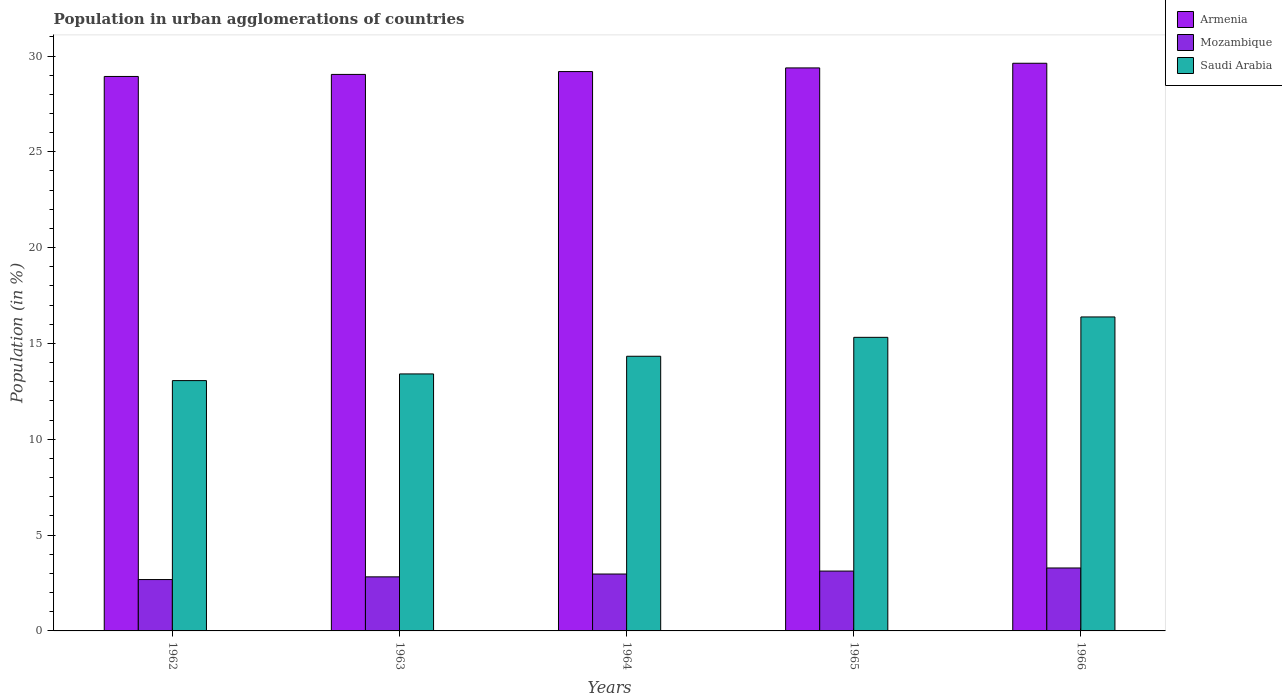How many different coloured bars are there?
Provide a succinct answer. 3. How many groups of bars are there?
Provide a succinct answer. 5. Are the number of bars per tick equal to the number of legend labels?
Give a very brief answer. Yes. Are the number of bars on each tick of the X-axis equal?
Your answer should be compact. Yes. How many bars are there on the 3rd tick from the left?
Give a very brief answer. 3. How many bars are there on the 3rd tick from the right?
Your answer should be compact. 3. What is the label of the 4th group of bars from the left?
Give a very brief answer. 1965. What is the percentage of population in urban agglomerations in Mozambique in 1966?
Your response must be concise. 3.28. Across all years, what is the maximum percentage of population in urban agglomerations in Saudi Arabia?
Provide a succinct answer. 16.38. Across all years, what is the minimum percentage of population in urban agglomerations in Armenia?
Keep it short and to the point. 28.93. In which year was the percentage of population in urban agglomerations in Saudi Arabia maximum?
Offer a terse response. 1966. What is the total percentage of population in urban agglomerations in Mozambique in the graph?
Give a very brief answer. 14.88. What is the difference between the percentage of population in urban agglomerations in Mozambique in 1962 and that in 1965?
Your response must be concise. -0.44. What is the difference between the percentage of population in urban agglomerations in Mozambique in 1966 and the percentage of population in urban agglomerations in Armenia in 1962?
Offer a very short reply. -25.65. What is the average percentage of population in urban agglomerations in Mozambique per year?
Give a very brief answer. 2.98. In the year 1964, what is the difference between the percentage of population in urban agglomerations in Saudi Arabia and percentage of population in urban agglomerations in Mozambique?
Your answer should be very brief. 11.36. What is the ratio of the percentage of population in urban agglomerations in Mozambique in 1962 to that in 1965?
Your answer should be very brief. 0.86. Is the percentage of population in urban agglomerations in Mozambique in 1964 less than that in 1966?
Your answer should be very brief. Yes. What is the difference between the highest and the second highest percentage of population in urban agglomerations in Saudi Arabia?
Offer a very short reply. 1.06. What is the difference between the highest and the lowest percentage of population in urban agglomerations in Mozambique?
Ensure brevity in your answer.  0.6. In how many years, is the percentage of population in urban agglomerations in Armenia greater than the average percentage of population in urban agglomerations in Armenia taken over all years?
Ensure brevity in your answer.  2. What does the 2nd bar from the left in 1965 represents?
Ensure brevity in your answer.  Mozambique. What does the 3rd bar from the right in 1964 represents?
Your answer should be very brief. Armenia. How many years are there in the graph?
Give a very brief answer. 5. Does the graph contain grids?
Ensure brevity in your answer.  No. How many legend labels are there?
Ensure brevity in your answer.  3. How are the legend labels stacked?
Your answer should be very brief. Vertical. What is the title of the graph?
Ensure brevity in your answer.  Population in urban agglomerations of countries. Does "Faeroe Islands" appear as one of the legend labels in the graph?
Your answer should be very brief. No. What is the label or title of the X-axis?
Give a very brief answer. Years. What is the label or title of the Y-axis?
Give a very brief answer. Population (in %). What is the Population (in %) in Armenia in 1962?
Give a very brief answer. 28.93. What is the Population (in %) of Mozambique in 1962?
Your response must be concise. 2.68. What is the Population (in %) in Saudi Arabia in 1962?
Offer a very short reply. 13.06. What is the Population (in %) of Armenia in 1963?
Give a very brief answer. 29.04. What is the Population (in %) in Mozambique in 1963?
Keep it short and to the point. 2.82. What is the Population (in %) of Saudi Arabia in 1963?
Offer a very short reply. 13.41. What is the Population (in %) in Armenia in 1964?
Offer a terse response. 29.19. What is the Population (in %) of Mozambique in 1964?
Keep it short and to the point. 2.97. What is the Population (in %) in Saudi Arabia in 1964?
Your answer should be compact. 14.33. What is the Population (in %) in Armenia in 1965?
Your answer should be compact. 29.38. What is the Population (in %) in Mozambique in 1965?
Keep it short and to the point. 3.12. What is the Population (in %) of Saudi Arabia in 1965?
Your answer should be compact. 15.32. What is the Population (in %) of Armenia in 1966?
Your response must be concise. 29.62. What is the Population (in %) in Mozambique in 1966?
Provide a short and direct response. 3.28. What is the Population (in %) of Saudi Arabia in 1966?
Give a very brief answer. 16.38. Across all years, what is the maximum Population (in %) in Armenia?
Provide a succinct answer. 29.62. Across all years, what is the maximum Population (in %) of Mozambique?
Provide a short and direct response. 3.28. Across all years, what is the maximum Population (in %) of Saudi Arabia?
Your answer should be very brief. 16.38. Across all years, what is the minimum Population (in %) in Armenia?
Keep it short and to the point. 28.93. Across all years, what is the minimum Population (in %) in Mozambique?
Make the answer very short. 2.68. Across all years, what is the minimum Population (in %) of Saudi Arabia?
Make the answer very short. 13.06. What is the total Population (in %) of Armenia in the graph?
Make the answer very short. 146.16. What is the total Population (in %) of Mozambique in the graph?
Provide a succinct answer. 14.88. What is the total Population (in %) in Saudi Arabia in the graph?
Offer a terse response. 72.51. What is the difference between the Population (in %) of Armenia in 1962 and that in 1963?
Ensure brevity in your answer.  -0.11. What is the difference between the Population (in %) of Mozambique in 1962 and that in 1963?
Offer a very short reply. -0.14. What is the difference between the Population (in %) of Saudi Arabia in 1962 and that in 1963?
Ensure brevity in your answer.  -0.35. What is the difference between the Population (in %) of Armenia in 1962 and that in 1964?
Make the answer very short. -0.26. What is the difference between the Population (in %) of Mozambique in 1962 and that in 1964?
Make the answer very short. -0.29. What is the difference between the Population (in %) of Saudi Arabia in 1962 and that in 1964?
Offer a terse response. -1.27. What is the difference between the Population (in %) of Armenia in 1962 and that in 1965?
Offer a terse response. -0.45. What is the difference between the Population (in %) of Mozambique in 1962 and that in 1965?
Give a very brief answer. -0.44. What is the difference between the Population (in %) of Saudi Arabia in 1962 and that in 1965?
Provide a succinct answer. -2.26. What is the difference between the Population (in %) in Armenia in 1962 and that in 1966?
Your response must be concise. -0.69. What is the difference between the Population (in %) in Mozambique in 1962 and that in 1966?
Your response must be concise. -0.6. What is the difference between the Population (in %) in Saudi Arabia in 1962 and that in 1966?
Make the answer very short. -3.32. What is the difference between the Population (in %) in Armenia in 1963 and that in 1964?
Your answer should be compact. -0.15. What is the difference between the Population (in %) in Mozambique in 1963 and that in 1964?
Make the answer very short. -0.15. What is the difference between the Population (in %) of Saudi Arabia in 1963 and that in 1964?
Your answer should be very brief. -0.92. What is the difference between the Population (in %) of Armenia in 1963 and that in 1965?
Give a very brief answer. -0.34. What is the difference between the Population (in %) of Mozambique in 1963 and that in 1965?
Ensure brevity in your answer.  -0.3. What is the difference between the Population (in %) in Saudi Arabia in 1963 and that in 1965?
Ensure brevity in your answer.  -1.91. What is the difference between the Population (in %) of Armenia in 1963 and that in 1966?
Keep it short and to the point. -0.58. What is the difference between the Population (in %) of Mozambique in 1963 and that in 1966?
Ensure brevity in your answer.  -0.46. What is the difference between the Population (in %) in Saudi Arabia in 1963 and that in 1966?
Give a very brief answer. -2.97. What is the difference between the Population (in %) of Armenia in 1964 and that in 1965?
Your answer should be very brief. -0.19. What is the difference between the Population (in %) of Mozambique in 1964 and that in 1965?
Offer a terse response. -0.15. What is the difference between the Population (in %) in Saudi Arabia in 1964 and that in 1965?
Ensure brevity in your answer.  -0.99. What is the difference between the Population (in %) of Armenia in 1964 and that in 1966?
Keep it short and to the point. -0.43. What is the difference between the Population (in %) of Mozambique in 1964 and that in 1966?
Provide a short and direct response. -0.32. What is the difference between the Population (in %) of Saudi Arabia in 1964 and that in 1966?
Your answer should be very brief. -2.05. What is the difference between the Population (in %) in Armenia in 1965 and that in 1966?
Keep it short and to the point. -0.24. What is the difference between the Population (in %) of Mozambique in 1965 and that in 1966?
Keep it short and to the point. -0.16. What is the difference between the Population (in %) of Saudi Arabia in 1965 and that in 1966?
Offer a very short reply. -1.06. What is the difference between the Population (in %) in Armenia in 1962 and the Population (in %) in Mozambique in 1963?
Your response must be concise. 26.11. What is the difference between the Population (in %) in Armenia in 1962 and the Population (in %) in Saudi Arabia in 1963?
Your answer should be compact. 15.52. What is the difference between the Population (in %) of Mozambique in 1962 and the Population (in %) of Saudi Arabia in 1963?
Give a very brief answer. -10.73. What is the difference between the Population (in %) in Armenia in 1962 and the Population (in %) in Mozambique in 1964?
Give a very brief answer. 25.96. What is the difference between the Population (in %) in Armenia in 1962 and the Population (in %) in Saudi Arabia in 1964?
Your answer should be compact. 14.6. What is the difference between the Population (in %) in Mozambique in 1962 and the Population (in %) in Saudi Arabia in 1964?
Your answer should be very brief. -11.65. What is the difference between the Population (in %) of Armenia in 1962 and the Population (in %) of Mozambique in 1965?
Give a very brief answer. 25.81. What is the difference between the Population (in %) in Armenia in 1962 and the Population (in %) in Saudi Arabia in 1965?
Offer a terse response. 13.61. What is the difference between the Population (in %) in Mozambique in 1962 and the Population (in %) in Saudi Arabia in 1965?
Keep it short and to the point. -12.64. What is the difference between the Population (in %) of Armenia in 1962 and the Population (in %) of Mozambique in 1966?
Offer a terse response. 25.65. What is the difference between the Population (in %) in Armenia in 1962 and the Population (in %) in Saudi Arabia in 1966?
Offer a terse response. 12.55. What is the difference between the Population (in %) in Mozambique in 1962 and the Population (in %) in Saudi Arabia in 1966?
Offer a terse response. -13.7. What is the difference between the Population (in %) of Armenia in 1963 and the Population (in %) of Mozambique in 1964?
Ensure brevity in your answer.  26.07. What is the difference between the Population (in %) in Armenia in 1963 and the Population (in %) in Saudi Arabia in 1964?
Provide a short and direct response. 14.71. What is the difference between the Population (in %) in Mozambique in 1963 and the Population (in %) in Saudi Arabia in 1964?
Your answer should be very brief. -11.51. What is the difference between the Population (in %) of Armenia in 1963 and the Population (in %) of Mozambique in 1965?
Provide a short and direct response. 25.92. What is the difference between the Population (in %) in Armenia in 1963 and the Population (in %) in Saudi Arabia in 1965?
Give a very brief answer. 13.72. What is the difference between the Population (in %) in Mozambique in 1963 and the Population (in %) in Saudi Arabia in 1965?
Your response must be concise. -12.5. What is the difference between the Population (in %) in Armenia in 1963 and the Population (in %) in Mozambique in 1966?
Give a very brief answer. 25.76. What is the difference between the Population (in %) in Armenia in 1963 and the Population (in %) in Saudi Arabia in 1966?
Make the answer very short. 12.66. What is the difference between the Population (in %) in Mozambique in 1963 and the Population (in %) in Saudi Arabia in 1966?
Offer a very short reply. -13.56. What is the difference between the Population (in %) of Armenia in 1964 and the Population (in %) of Mozambique in 1965?
Give a very brief answer. 26.06. What is the difference between the Population (in %) in Armenia in 1964 and the Population (in %) in Saudi Arabia in 1965?
Your answer should be compact. 13.87. What is the difference between the Population (in %) in Mozambique in 1964 and the Population (in %) in Saudi Arabia in 1965?
Provide a succinct answer. -12.35. What is the difference between the Population (in %) of Armenia in 1964 and the Population (in %) of Mozambique in 1966?
Your response must be concise. 25.9. What is the difference between the Population (in %) in Armenia in 1964 and the Population (in %) in Saudi Arabia in 1966?
Your answer should be compact. 12.8. What is the difference between the Population (in %) of Mozambique in 1964 and the Population (in %) of Saudi Arabia in 1966?
Provide a succinct answer. -13.42. What is the difference between the Population (in %) of Armenia in 1965 and the Population (in %) of Mozambique in 1966?
Offer a very short reply. 26.09. What is the difference between the Population (in %) of Armenia in 1965 and the Population (in %) of Saudi Arabia in 1966?
Offer a terse response. 13. What is the difference between the Population (in %) in Mozambique in 1965 and the Population (in %) in Saudi Arabia in 1966?
Your answer should be very brief. -13.26. What is the average Population (in %) of Armenia per year?
Offer a very short reply. 29.23. What is the average Population (in %) of Mozambique per year?
Provide a short and direct response. 2.98. What is the average Population (in %) of Saudi Arabia per year?
Make the answer very short. 14.5. In the year 1962, what is the difference between the Population (in %) in Armenia and Population (in %) in Mozambique?
Your answer should be very brief. 26.25. In the year 1962, what is the difference between the Population (in %) of Armenia and Population (in %) of Saudi Arabia?
Your response must be concise. 15.87. In the year 1962, what is the difference between the Population (in %) in Mozambique and Population (in %) in Saudi Arabia?
Your answer should be compact. -10.38. In the year 1963, what is the difference between the Population (in %) in Armenia and Population (in %) in Mozambique?
Provide a succinct answer. 26.22. In the year 1963, what is the difference between the Population (in %) of Armenia and Population (in %) of Saudi Arabia?
Offer a terse response. 15.63. In the year 1963, what is the difference between the Population (in %) in Mozambique and Population (in %) in Saudi Arabia?
Keep it short and to the point. -10.59. In the year 1964, what is the difference between the Population (in %) in Armenia and Population (in %) in Mozambique?
Offer a very short reply. 26.22. In the year 1964, what is the difference between the Population (in %) in Armenia and Population (in %) in Saudi Arabia?
Offer a very short reply. 14.86. In the year 1964, what is the difference between the Population (in %) of Mozambique and Population (in %) of Saudi Arabia?
Provide a succinct answer. -11.36. In the year 1965, what is the difference between the Population (in %) of Armenia and Population (in %) of Mozambique?
Provide a short and direct response. 26.26. In the year 1965, what is the difference between the Population (in %) in Armenia and Population (in %) in Saudi Arabia?
Ensure brevity in your answer.  14.06. In the year 1965, what is the difference between the Population (in %) of Mozambique and Population (in %) of Saudi Arabia?
Your answer should be compact. -12.2. In the year 1966, what is the difference between the Population (in %) of Armenia and Population (in %) of Mozambique?
Your answer should be very brief. 26.34. In the year 1966, what is the difference between the Population (in %) of Armenia and Population (in %) of Saudi Arabia?
Give a very brief answer. 13.24. In the year 1966, what is the difference between the Population (in %) in Mozambique and Population (in %) in Saudi Arabia?
Make the answer very short. -13.1. What is the ratio of the Population (in %) of Mozambique in 1962 to that in 1963?
Offer a very short reply. 0.95. What is the ratio of the Population (in %) of Mozambique in 1962 to that in 1964?
Keep it short and to the point. 0.9. What is the ratio of the Population (in %) in Saudi Arabia in 1962 to that in 1964?
Keep it short and to the point. 0.91. What is the ratio of the Population (in %) of Armenia in 1962 to that in 1965?
Make the answer very short. 0.98. What is the ratio of the Population (in %) in Mozambique in 1962 to that in 1965?
Give a very brief answer. 0.86. What is the ratio of the Population (in %) of Saudi Arabia in 1962 to that in 1965?
Provide a succinct answer. 0.85. What is the ratio of the Population (in %) of Armenia in 1962 to that in 1966?
Provide a short and direct response. 0.98. What is the ratio of the Population (in %) of Mozambique in 1962 to that in 1966?
Your response must be concise. 0.82. What is the ratio of the Population (in %) of Saudi Arabia in 1962 to that in 1966?
Make the answer very short. 0.8. What is the ratio of the Population (in %) of Mozambique in 1963 to that in 1964?
Keep it short and to the point. 0.95. What is the ratio of the Population (in %) in Saudi Arabia in 1963 to that in 1964?
Make the answer very short. 0.94. What is the ratio of the Population (in %) in Armenia in 1963 to that in 1965?
Your answer should be compact. 0.99. What is the ratio of the Population (in %) of Mozambique in 1963 to that in 1965?
Your answer should be very brief. 0.9. What is the ratio of the Population (in %) of Saudi Arabia in 1963 to that in 1965?
Your response must be concise. 0.88. What is the ratio of the Population (in %) of Armenia in 1963 to that in 1966?
Give a very brief answer. 0.98. What is the ratio of the Population (in %) of Mozambique in 1963 to that in 1966?
Ensure brevity in your answer.  0.86. What is the ratio of the Population (in %) in Saudi Arabia in 1963 to that in 1966?
Your response must be concise. 0.82. What is the ratio of the Population (in %) of Armenia in 1964 to that in 1965?
Your answer should be very brief. 0.99. What is the ratio of the Population (in %) in Mozambique in 1964 to that in 1965?
Offer a very short reply. 0.95. What is the ratio of the Population (in %) in Saudi Arabia in 1964 to that in 1965?
Your response must be concise. 0.94. What is the ratio of the Population (in %) of Mozambique in 1964 to that in 1966?
Provide a short and direct response. 0.9. What is the ratio of the Population (in %) in Saudi Arabia in 1964 to that in 1966?
Make the answer very short. 0.87. What is the ratio of the Population (in %) in Mozambique in 1965 to that in 1966?
Offer a terse response. 0.95. What is the ratio of the Population (in %) in Saudi Arabia in 1965 to that in 1966?
Offer a terse response. 0.94. What is the difference between the highest and the second highest Population (in %) in Armenia?
Make the answer very short. 0.24. What is the difference between the highest and the second highest Population (in %) in Mozambique?
Your answer should be very brief. 0.16. What is the difference between the highest and the second highest Population (in %) in Saudi Arabia?
Make the answer very short. 1.06. What is the difference between the highest and the lowest Population (in %) of Armenia?
Keep it short and to the point. 0.69. What is the difference between the highest and the lowest Population (in %) in Mozambique?
Provide a short and direct response. 0.6. What is the difference between the highest and the lowest Population (in %) in Saudi Arabia?
Offer a very short reply. 3.32. 